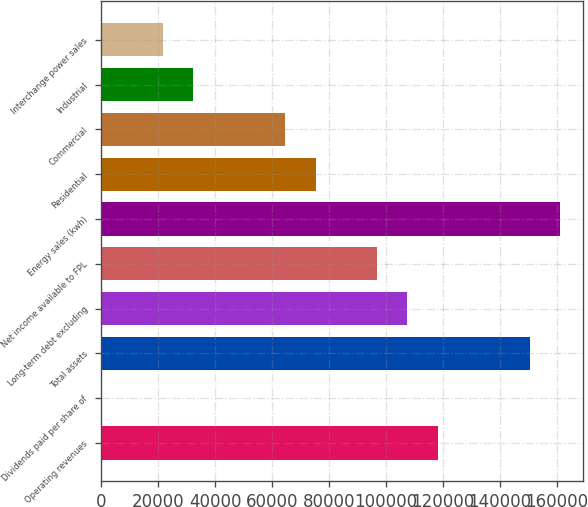Convert chart to OTSL. <chart><loc_0><loc_0><loc_500><loc_500><bar_chart><fcel>Operating revenues<fcel>Dividends paid per share of<fcel>Total assets<fcel>Long-term debt excluding<fcel>Net income available to FPL<fcel>Energy sales (kwh)<fcel>Residential<fcel>Commercial<fcel>Industrial<fcel>Interchange power sales<nl><fcel>118264<fcel>1.5<fcel>150518<fcel>107513<fcel>96761.9<fcel>161269<fcel>75259.6<fcel>64508.4<fcel>32255<fcel>21503.8<nl></chart> 